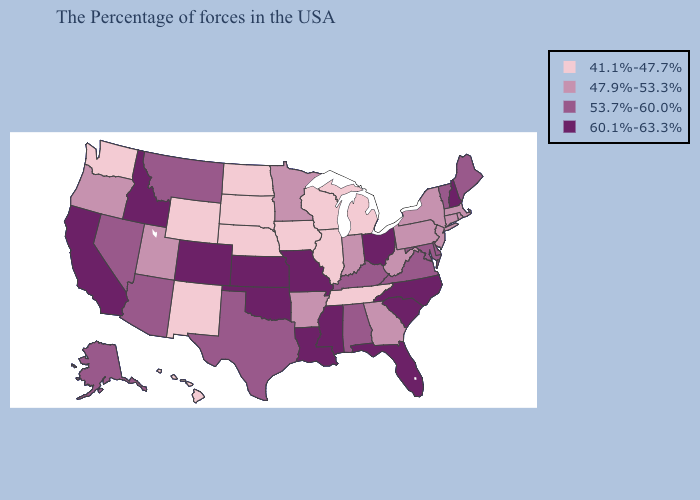Name the states that have a value in the range 60.1%-63.3%?
Write a very short answer. New Hampshire, North Carolina, South Carolina, Ohio, Florida, Mississippi, Louisiana, Missouri, Kansas, Oklahoma, Colorado, Idaho, California. Does Indiana have the lowest value in the MidWest?
Concise answer only. No. Name the states that have a value in the range 47.9%-53.3%?
Answer briefly. Massachusetts, Rhode Island, Connecticut, New York, New Jersey, Pennsylvania, West Virginia, Georgia, Indiana, Arkansas, Minnesota, Utah, Oregon. What is the highest value in states that border Louisiana?
Short answer required. 60.1%-63.3%. Name the states that have a value in the range 60.1%-63.3%?
Write a very short answer. New Hampshire, North Carolina, South Carolina, Ohio, Florida, Mississippi, Louisiana, Missouri, Kansas, Oklahoma, Colorado, Idaho, California. Name the states that have a value in the range 41.1%-47.7%?
Short answer required. Michigan, Tennessee, Wisconsin, Illinois, Iowa, Nebraska, South Dakota, North Dakota, Wyoming, New Mexico, Washington, Hawaii. Name the states that have a value in the range 41.1%-47.7%?
Write a very short answer. Michigan, Tennessee, Wisconsin, Illinois, Iowa, Nebraska, South Dakota, North Dakota, Wyoming, New Mexico, Washington, Hawaii. Among the states that border Louisiana , which have the lowest value?
Give a very brief answer. Arkansas. Does California have the highest value in the USA?
Answer briefly. Yes. Name the states that have a value in the range 41.1%-47.7%?
Answer briefly. Michigan, Tennessee, Wisconsin, Illinois, Iowa, Nebraska, South Dakota, North Dakota, Wyoming, New Mexico, Washington, Hawaii. Name the states that have a value in the range 60.1%-63.3%?
Be succinct. New Hampshire, North Carolina, South Carolina, Ohio, Florida, Mississippi, Louisiana, Missouri, Kansas, Oklahoma, Colorado, Idaho, California. What is the highest value in the USA?
Short answer required. 60.1%-63.3%. What is the highest value in states that border North Dakota?
Be succinct. 53.7%-60.0%. Does Tennessee have the same value as Kansas?
Concise answer only. No. Does Arizona have the same value as Vermont?
Be succinct. Yes. 